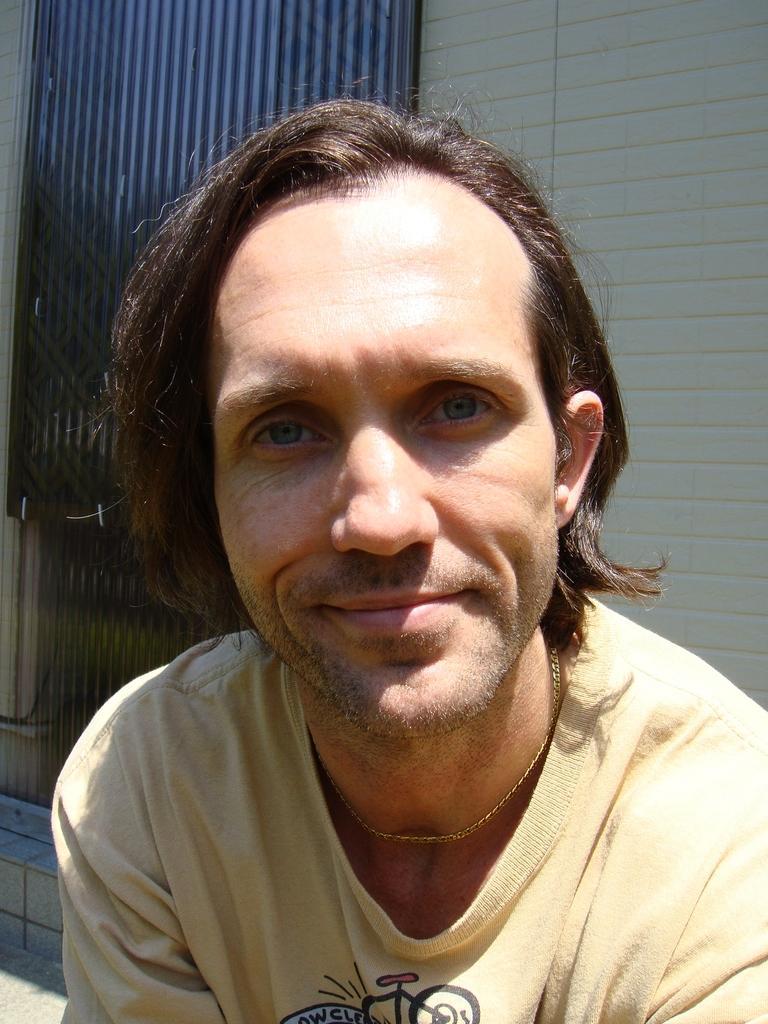Describe this image in one or two sentences. In this image there is a person wearing a shirt. Behind him there is a wall having metal gate. 